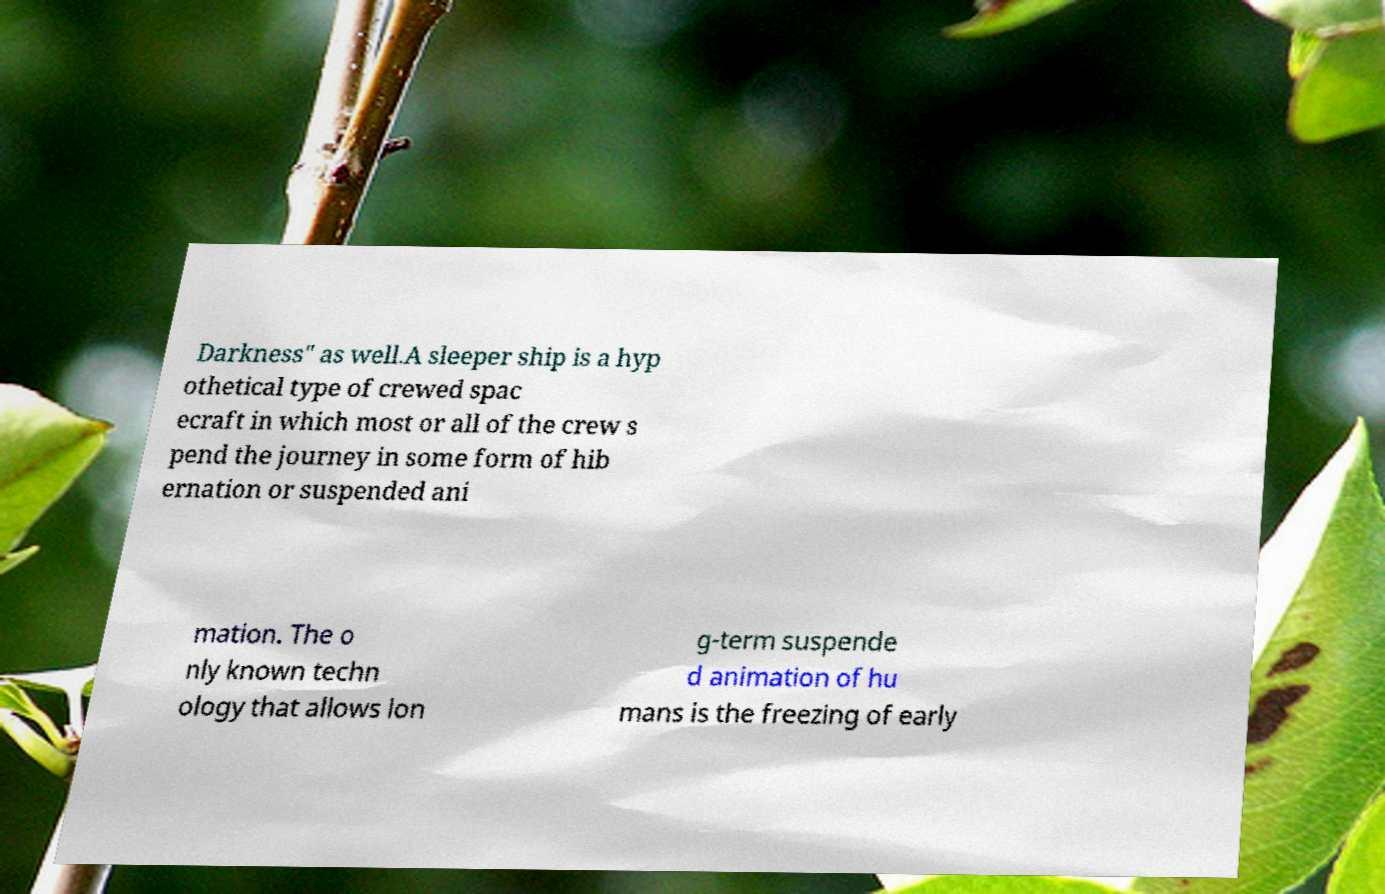There's text embedded in this image that I need extracted. Can you transcribe it verbatim? Darkness" as well.A sleeper ship is a hyp othetical type of crewed spac ecraft in which most or all of the crew s pend the journey in some form of hib ernation or suspended ani mation. The o nly known techn ology that allows lon g-term suspende d animation of hu mans is the freezing of early 